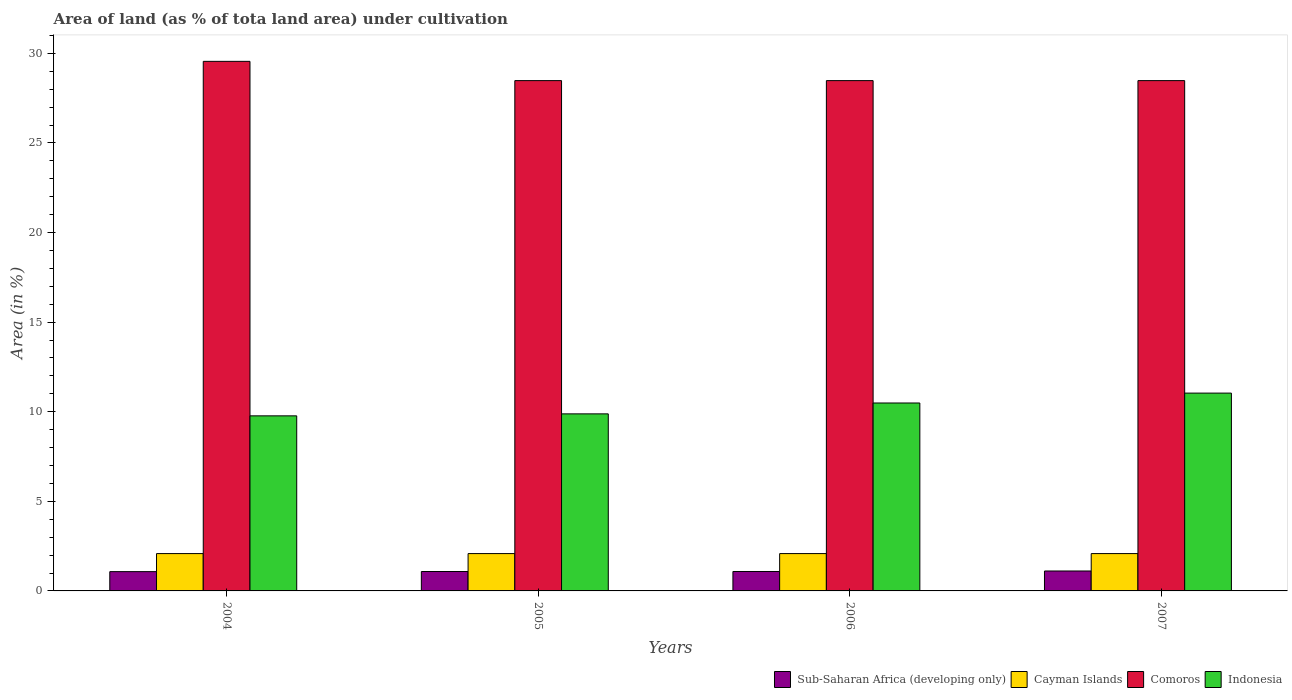How many different coloured bars are there?
Your answer should be compact. 4. Are the number of bars per tick equal to the number of legend labels?
Provide a succinct answer. Yes. How many bars are there on the 1st tick from the left?
Your answer should be compact. 4. How many bars are there on the 1st tick from the right?
Your response must be concise. 4. What is the label of the 4th group of bars from the left?
Your answer should be compact. 2007. What is the percentage of land under cultivation in Indonesia in 2005?
Your answer should be very brief. 9.88. Across all years, what is the maximum percentage of land under cultivation in Cayman Islands?
Provide a short and direct response. 2.08. Across all years, what is the minimum percentage of land under cultivation in Indonesia?
Your answer should be compact. 9.77. What is the total percentage of land under cultivation in Comoros in the graph?
Provide a succinct answer. 114.99. What is the difference between the percentage of land under cultivation in Sub-Saharan Africa (developing only) in 2005 and that in 2006?
Your response must be concise. -0. What is the difference between the percentage of land under cultivation in Sub-Saharan Africa (developing only) in 2005 and the percentage of land under cultivation in Cayman Islands in 2006?
Offer a terse response. -1. What is the average percentage of land under cultivation in Indonesia per year?
Your response must be concise. 10.29. In the year 2004, what is the difference between the percentage of land under cultivation in Comoros and percentage of land under cultivation in Sub-Saharan Africa (developing only)?
Provide a succinct answer. 28.48. What is the ratio of the percentage of land under cultivation in Sub-Saharan Africa (developing only) in 2005 to that in 2007?
Offer a terse response. 0.97. Is the difference between the percentage of land under cultivation in Comoros in 2005 and 2006 greater than the difference between the percentage of land under cultivation in Sub-Saharan Africa (developing only) in 2005 and 2006?
Offer a terse response. Yes. What is the difference between the highest and the second highest percentage of land under cultivation in Comoros?
Provide a succinct answer. 1.07. What is the difference between the highest and the lowest percentage of land under cultivation in Sub-Saharan Africa (developing only)?
Keep it short and to the point. 0.04. Is the sum of the percentage of land under cultivation in Cayman Islands in 2005 and 2006 greater than the maximum percentage of land under cultivation in Comoros across all years?
Your response must be concise. No. What does the 1st bar from the left in 2007 represents?
Your answer should be compact. Sub-Saharan Africa (developing only). Is it the case that in every year, the sum of the percentage of land under cultivation in Cayman Islands and percentage of land under cultivation in Comoros is greater than the percentage of land under cultivation in Indonesia?
Offer a terse response. Yes. Are all the bars in the graph horizontal?
Provide a short and direct response. No. Does the graph contain any zero values?
Your answer should be compact. No. Does the graph contain grids?
Offer a terse response. No. What is the title of the graph?
Provide a short and direct response. Area of land (as % of tota land area) under cultivation. Does "Kyrgyz Republic" appear as one of the legend labels in the graph?
Provide a succinct answer. No. What is the label or title of the Y-axis?
Keep it short and to the point. Area (in %). What is the Area (in %) of Sub-Saharan Africa (developing only) in 2004?
Offer a very short reply. 1.08. What is the Area (in %) of Cayman Islands in 2004?
Your answer should be compact. 2.08. What is the Area (in %) of Comoros in 2004?
Make the answer very short. 29.55. What is the Area (in %) of Indonesia in 2004?
Provide a succinct answer. 9.77. What is the Area (in %) in Sub-Saharan Africa (developing only) in 2005?
Give a very brief answer. 1.08. What is the Area (in %) in Cayman Islands in 2005?
Provide a succinct answer. 2.08. What is the Area (in %) of Comoros in 2005?
Your response must be concise. 28.48. What is the Area (in %) of Indonesia in 2005?
Your answer should be compact. 9.88. What is the Area (in %) in Sub-Saharan Africa (developing only) in 2006?
Make the answer very short. 1.08. What is the Area (in %) in Cayman Islands in 2006?
Your answer should be very brief. 2.08. What is the Area (in %) of Comoros in 2006?
Your answer should be compact. 28.48. What is the Area (in %) of Indonesia in 2006?
Offer a terse response. 10.49. What is the Area (in %) of Sub-Saharan Africa (developing only) in 2007?
Provide a succinct answer. 1.11. What is the Area (in %) of Cayman Islands in 2007?
Provide a short and direct response. 2.08. What is the Area (in %) of Comoros in 2007?
Keep it short and to the point. 28.48. What is the Area (in %) in Indonesia in 2007?
Your response must be concise. 11.04. Across all years, what is the maximum Area (in %) in Sub-Saharan Africa (developing only)?
Provide a succinct answer. 1.11. Across all years, what is the maximum Area (in %) of Cayman Islands?
Your response must be concise. 2.08. Across all years, what is the maximum Area (in %) in Comoros?
Your answer should be very brief. 29.55. Across all years, what is the maximum Area (in %) of Indonesia?
Provide a short and direct response. 11.04. Across all years, what is the minimum Area (in %) in Sub-Saharan Africa (developing only)?
Your answer should be very brief. 1.08. Across all years, what is the minimum Area (in %) in Cayman Islands?
Offer a very short reply. 2.08. Across all years, what is the minimum Area (in %) of Comoros?
Your answer should be compact. 28.48. Across all years, what is the minimum Area (in %) of Indonesia?
Your answer should be very brief. 9.77. What is the total Area (in %) in Sub-Saharan Africa (developing only) in the graph?
Make the answer very short. 4.36. What is the total Area (in %) in Cayman Islands in the graph?
Make the answer very short. 8.33. What is the total Area (in %) in Comoros in the graph?
Offer a terse response. 114.99. What is the total Area (in %) of Indonesia in the graph?
Make the answer very short. 41.18. What is the difference between the Area (in %) of Sub-Saharan Africa (developing only) in 2004 and that in 2005?
Offer a very short reply. -0.01. What is the difference between the Area (in %) in Cayman Islands in 2004 and that in 2005?
Ensure brevity in your answer.  0. What is the difference between the Area (in %) in Comoros in 2004 and that in 2005?
Keep it short and to the point. 1.07. What is the difference between the Area (in %) in Indonesia in 2004 and that in 2005?
Your answer should be compact. -0.11. What is the difference between the Area (in %) of Sub-Saharan Africa (developing only) in 2004 and that in 2006?
Ensure brevity in your answer.  -0.01. What is the difference between the Area (in %) of Cayman Islands in 2004 and that in 2006?
Offer a terse response. 0. What is the difference between the Area (in %) in Comoros in 2004 and that in 2006?
Your answer should be very brief. 1.07. What is the difference between the Area (in %) in Indonesia in 2004 and that in 2006?
Provide a succinct answer. -0.72. What is the difference between the Area (in %) in Sub-Saharan Africa (developing only) in 2004 and that in 2007?
Offer a terse response. -0.04. What is the difference between the Area (in %) of Comoros in 2004 and that in 2007?
Your answer should be compact. 1.07. What is the difference between the Area (in %) of Indonesia in 2004 and that in 2007?
Your response must be concise. -1.27. What is the difference between the Area (in %) of Sub-Saharan Africa (developing only) in 2005 and that in 2006?
Give a very brief answer. -0. What is the difference between the Area (in %) in Cayman Islands in 2005 and that in 2006?
Provide a succinct answer. 0. What is the difference between the Area (in %) in Indonesia in 2005 and that in 2006?
Give a very brief answer. -0.61. What is the difference between the Area (in %) of Sub-Saharan Africa (developing only) in 2005 and that in 2007?
Offer a terse response. -0.03. What is the difference between the Area (in %) in Cayman Islands in 2005 and that in 2007?
Give a very brief answer. 0. What is the difference between the Area (in %) in Indonesia in 2005 and that in 2007?
Make the answer very short. -1.16. What is the difference between the Area (in %) of Sub-Saharan Africa (developing only) in 2006 and that in 2007?
Keep it short and to the point. -0.03. What is the difference between the Area (in %) in Cayman Islands in 2006 and that in 2007?
Offer a terse response. 0. What is the difference between the Area (in %) of Comoros in 2006 and that in 2007?
Give a very brief answer. 0. What is the difference between the Area (in %) of Indonesia in 2006 and that in 2007?
Ensure brevity in your answer.  -0.55. What is the difference between the Area (in %) of Sub-Saharan Africa (developing only) in 2004 and the Area (in %) of Cayman Islands in 2005?
Keep it short and to the point. -1.01. What is the difference between the Area (in %) of Sub-Saharan Africa (developing only) in 2004 and the Area (in %) of Comoros in 2005?
Your answer should be compact. -27.4. What is the difference between the Area (in %) of Sub-Saharan Africa (developing only) in 2004 and the Area (in %) of Indonesia in 2005?
Provide a short and direct response. -8.8. What is the difference between the Area (in %) of Cayman Islands in 2004 and the Area (in %) of Comoros in 2005?
Your answer should be compact. -26.4. What is the difference between the Area (in %) in Cayman Islands in 2004 and the Area (in %) in Indonesia in 2005?
Provide a short and direct response. -7.8. What is the difference between the Area (in %) in Comoros in 2004 and the Area (in %) in Indonesia in 2005?
Your answer should be very brief. 19.67. What is the difference between the Area (in %) in Sub-Saharan Africa (developing only) in 2004 and the Area (in %) in Cayman Islands in 2006?
Offer a very short reply. -1.01. What is the difference between the Area (in %) in Sub-Saharan Africa (developing only) in 2004 and the Area (in %) in Comoros in 2006?
Your answer should be compact. -27.4. What is the difference between the Area (in %) in Sub-Saharan Africa (developing only) in 2004 and the Area (in %) in Indonesia in 2006?
Offer a very short reply. -9.41. What is the difference between the Area (in %) in Cayman Islands in 2004 and the Area (in %) in Comoros in 2006?
Offer a terse response. -26.4. What is the difference between the Area (in %) in Cayman Islands in 2004 and the Area (in %) in Indonesia in 2006?
Keep it short and to the point. -8.4. What is the difference between the Area (in %) in Comoros in 2004 and the Area (in %) in Indonesia in 2006?
Give a very brief answer. 19.07. What is the difference between the Area (in %) of Sub-Saharan Africa (developing only) in 2004 and the Area (in %) of Cayman Islands in 2007?
Provide a succinct answer. -1.01. What is the difference between the Area (in %) in Sub-Saharan Africa (developing only) in 2004 and the Area (in %) in Comoros in 2007?
Your answer should be very brief. -27.4. What is the difference between the Area (in %) in Sub-Saharan Africa (developing only) in 2004 and the Area (in %) in Indonesia in 2007?
Give a very brief answer. -9.96. What is the difference between the Area (in %) in Cayman Islands in 2004 and the Area (in %) in Comoros in 2007?
Make the answer very short. -26.4. What is the difference between the Area (in %) of Cayman Islands in 2004 and the Area (in %) of Indonesia in 2007?
Provide a short and direct response. -8.96. What is the difference between the Area (in %) of Comoros in 2004 and the Area (in %) of Indonesia in 2007?
Ensure brevity in your answer.  18.51. What is the difference between the Area (in %) of Sub-Saharan Africa (developing only) in 2005 and the Area (in %) of Cayman Islands in 2006?
Offer a very short reply. -1. What is the difference between the Area (in %) in Sub-Saharan Africa (developing only) in 2005 and the Area (in %) in Comoros in 2006?
Give a very brief answer. -27.4. What is the difference between the Area (in %) in Sub-Saharan Africa (developing only) in 2005 and the Area (in %) in Indonesia in 2006?
Provide a short and direct response. -9.4. What is the difference between the Area (in %) in Cayman Islands in 2005 and the Area (in %) in Comoros in 2006?
Ensure brevity in your answer.  -26.4. What is the difference between the Area (in %) in Cayman Islands in 2005 and the Area (in %) in Indonesia in 2006?
Offer a terse response. -8.4. What is the difference between the Area (in %) of Comoros in 2005 and the Area (in %) of Indonesia in 2006?
Give a very brief answer. 17.99. What is the difference between the Area (in %) of Sub-Saharan Africa (developing only) in 2005 and the Area (in %) of Cayman Islands in 2007?
Provide a succinct answer. -1. What is the difference between the Area (in %) of Sub-Saharan Africa (developing only) in 2005 and the Area (in %) of Comoros in 2007?
Provide a short and direct response. -27.4. What is the difference between the Area (in %) in Sub-Saharan Africa (developing only) in 2005 and the Area (in %) in Indonesia in 2007?
Your response must be concise. -9.96. What is the difference between the Area (in %) of Cayman Islands in 2005 and the Area (in %) of Comoros in 2007?
Ensure brevity in your answer.  -26.4. What is the difference between the Area (in %) of Cayman Islands in 2005 and the Area (in %) of Indonesia in 2007?
Offer a very short reply. -8.96. What is the difference between the Area (in %) in Comoros in 2005 and the Area (in %) in Indonesia in 2007?
Your answer should be very brief. 17.44. What is the difference between the Area (in %) of Sub-Saharan Africa (developing only) in 2006 and the Area (in %) of Cayman Islands in 2007?
Your response must be concise. -1. What is the difference between the Area (in %) of Sub-Saharan Africa (developing only) in 2006 and the Area (in %) of Comoros in 2007?
Keep it short and to the point. -27.4. What is the difference between the Area (in %) in Sub-Saharan Africa (developing only) in 2006 and the Area (in %) in Indonesia in 2007?
Offer a terse response. -9.96. What is the difference between the Area (in %) of Cayman Islands in 2006 and the Area (in %) of Comoros in 2007?
Your answer should be very brief. -26.4. What is the difference between the Area (in %) of Cayman Islands in 2006 and the Area (in %) of Indonesia in 2007?
Provide a short and direct response. -8.96. What is the difference between the Area (in %) in Comoros in 2006 and the Area (in %) in Indonesia in 2007?
Give a very brief answer. 17.44. What is the average Area (in %) in Sub-Saharan Africa (developing only) per year?
Keep it short and to the point. 1.09. What is the average Area (in %) in Cayman Islands per year?
Offer a very short reply. 2.08. What is the average Area (in %) in Comoros per year?
Your answer should be very brief. 28.75. What is the average Area (in %) in Indonesia per year?
Ensure brevity in your answer.  10.29. In the year 2004, what is the difference between the Area (in %) in Sub-Saharan Africa (developing only) and Area (in %) in Cayman Islands?
Offer a very short reply. -1.01. In the year 2004, what is the difference between the Area (in %) in Sub-Saharan Africa (developing only) and Area (in %) in Comoros?
Keep it short and to the point. -28.48. In the year 2004, what is the difference between the Area (in %) of Sub-Saharan Africa (developing only) and Area (in %) of Indonesia?
Provide a succinct answer. -8.69. In the year 2004, what is the difference between the Area (in %) of Cayman Islands and Area (in %) of Comoros?
Make the answer very short. -27.47. In the year 2004, what is the difference between the Area (in %) of Cayman Islands and Area (in %) of Indonesia?
Your response must be concise. -7.69. In the year 2004, what is the difference between the Area (in %) in Comoros and Area (in %) in Indonesia?
Offer a terse response. 19.78. In the year 2005, what is the difference between the Area (in %) in Sub-Saharan Africa (developing only) and Area (in %) in Cayman Islands?
Ensure brevity in your answer.  -1. In the year 2005, what is the difference between the Area (in %) of Sub-Saharan Africa (developing only) and Area (in %) of Comoros?
Your answer should be compact. -27.4. In the year 2005, what is the difference between the Area (in %) of Sub-Saharan Africa (developing only) and Area (in %) of Indonesia?
Make the answer very short. -8.8. In the year 2005, what is the difference between the Area (in %) in Cayman Islands and Area (in %) in Comoros?
Keep it short and to the point. -26.4. In the year 2005, what is the difference between the Area (in %) of Cayman Islands and Area (in %) of Indonesia?
Offer a very short reply. -7.8. In the year 2005, what is the difference between the Area (in %) in Comoros and Area (in %) in Indonesia?
Provide a succinct answer. 18.6. In the year 2006, what is the difference between the Area (in %) of Sub-Saharan Africa (developing only) and Area (in %) of Cayman Islands?
Your answer should be very brief. -1. In the year 2006, what is the difference between the Area (in %) in Sub-Saharan Africa (developing only) and Area (in %) in Comoros?
Offer a very short reply. -27.4. In the year 2006, what is the difference between the Area (in %) in Sub-Saharan Africa (developing only) and Area (in %) in Indonesia?
Your answer should be compact. -9.4. In the year 2006, what is the difference between the Area (in %) of Cayman Islands and Area (in %) of Comoros?
Keep it short and to the point. -26.4. In the year 2006, what is the difference between the Area (in %) of Cayman Islands and Area (in %) of Indonesia?
Provide a succinct answer. -8.4. In the year 2006, what is the difference between the Area (in %) of Comoros and Area (in %) of Indonesia?
Your answer should be very brief. 17.99. In the year 2007, what is the difference between the Area (in %) in Sub-Saharan Africa (developing only) and Area (in %) in Cayman Islands?
Ensure brevity in your answer.  -0.97. In the year 2007, what is the difference between the Area (in %) in Sub-Saharan Africa (developing only) and Area (in %) in Comoros?
Your answer should be very brief. -27.37. In the year 2007, what is the difference between the Area (in %) of Sub-Saharan Africa (developing only) and Area (in %) of Indonesia?
Offer a terse response. -9.93. In the year 2007, what is the difference between the Area (in %) in Cayman Islands and Area (in %) in Comoros?
Offer a very short reply. -26.4. In the year 2007, what is the difference between the Area (in %) in Cayman Islands and Area (in %) in Indonesia?
Your response must be concise. -8.96. In the year 2007, what is the difference between the Area (in %) in Comoros and Area (in %) in Indonesia?
Your answer should be very brief. 17.44. What is the ratio of the Area (in %) in Comoros in 2004 to that in 2005?
Make the answer very short. 1.04. What is the ratio of the Area (in %) of Cayman Islands in 2004 to that in 2006?
Provide a succinct answer. 1. What is the ratio of the Area (in %) in Comoros in 2004 to that in 2006?
Offer a very short reply. 1.04. What is the ratio of the Area (in %) of Indonesia in 2004 to that in 2006?
Provide a succinct answer. 0.93. What is the ratio of the Area (in %) in Comoros in 2004 to that in 2007?
Give a very brief answer. 1.04. What is the ratio of the Area (in %) in Indonesia in 2004 to that in 2007?
Provide a succinct answer. 0.89. What is the ratio of the Area (in %) of Sub-Saharan Africa (developing only) in 2005 to that in 2006?
Make the answer very short. 1. What is the ratio of the Area (in %) in Cayman Islands in 2005 to that in 2006?
Your response must be concise. 1. What is the ratio of the Area (in %) of Indonesia in 2005 to that in 2006?
Give a very brief answer. 0.94. What is the ratio of the Area (in %) in Sub-Saharan Africa (developing only) in 2005 to that in 2007?
Your answer should be compact. 0.97. What is the ratio of the Area (in %) in Cayman Islands in 2005 to that in 2007?
Provide a short and direct response. 1. What is the ratio of the Area (in %) of Indonesia in 2005 to that in 2007?
Ensure brevity in your answer.  0.9. What is the ratio of the Area (in %) of Sub-Saharan Africa (developing only) in 2006 to that in 2007?
Make the answer very short. 0.97. What is the ratio of the Area (in %) in Comoros in 2006 to that in 2007?
Offer a very short reply. 1. What is the ratio of the Area (in %) in Indonesia in 2006 to that in 2007?
Give a very brief answer. 0.95. What is the difference between the highest and the second highest Area (in %) of Sub-Saharan Africa (developing only)?
Keep it short and to the point. 0.03. What is the difference between the highest and the second highest Area (in %) of Comoros?
Offer a terse response. 1.07. What is the difference between the highest and the second highest Area (in %) of Indonesia?
Ensure brevity in your answer.  0.55. What is the difference between the highest and the lowest Area (in %) of Sub-Saharan Africa (developing only)?
Your answer should be very brief. 0.04. What is the difference between the highest and the lowest Area (in %) in Comoros?
Provide a succinct answer. 1.07. What is the difference between the highest and the lowest Area (in %) in Indonesia?
Make the answer very short. 1.27. 